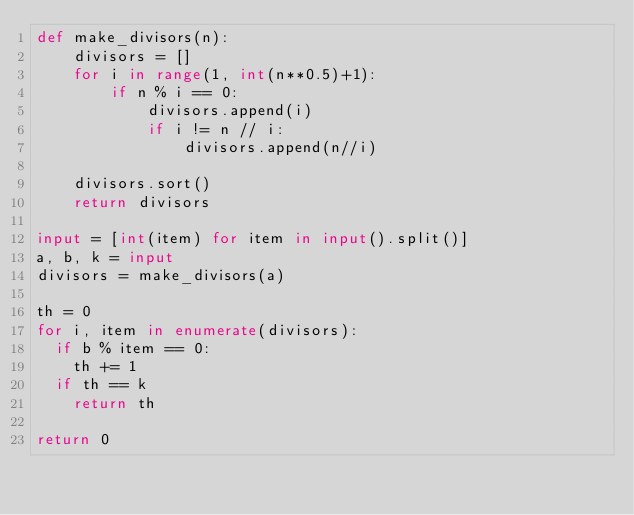Convert code to text. <code><loc_0><loc_0><loc_500><loc_500><_Python_>def make_divisors(n):
    divisors = []
    for i in range(1, int(n**0.5)+1):
        if n % i == 0:
            divisors.append(i)
            if i != n // i:
                divisors.append(n//i)

    divisors.sort()
    return divisors

input = [int(item) for item in input().split()]
a, b, k = input
divisors = make_divisors(a)

th = 0
for i, item in enumerate(divisors):
  if b % item == 0:
    th += 1
  if th == k
    return th

return 0</code> 